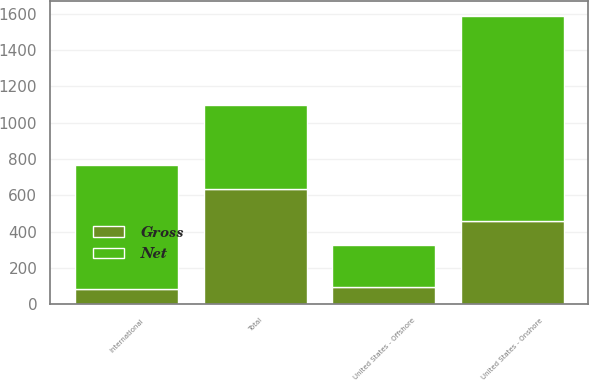Convert chart to OTSL. <chart><loc_0><loc_0><loc_500><loc_500><stacked_bar_chart><ecel><fcel>United States - Onshore<fcel>United States - Offshore<fcel>International<fcel>Total<nl><fcel>Net<fcel>1131<fcel>232.5<fcel>687<fcel>458.7<nl><fcel>Gross<fcel>458.7<fcel>95.7<fcel>81.3<fcel>635.7<nl></chart> 